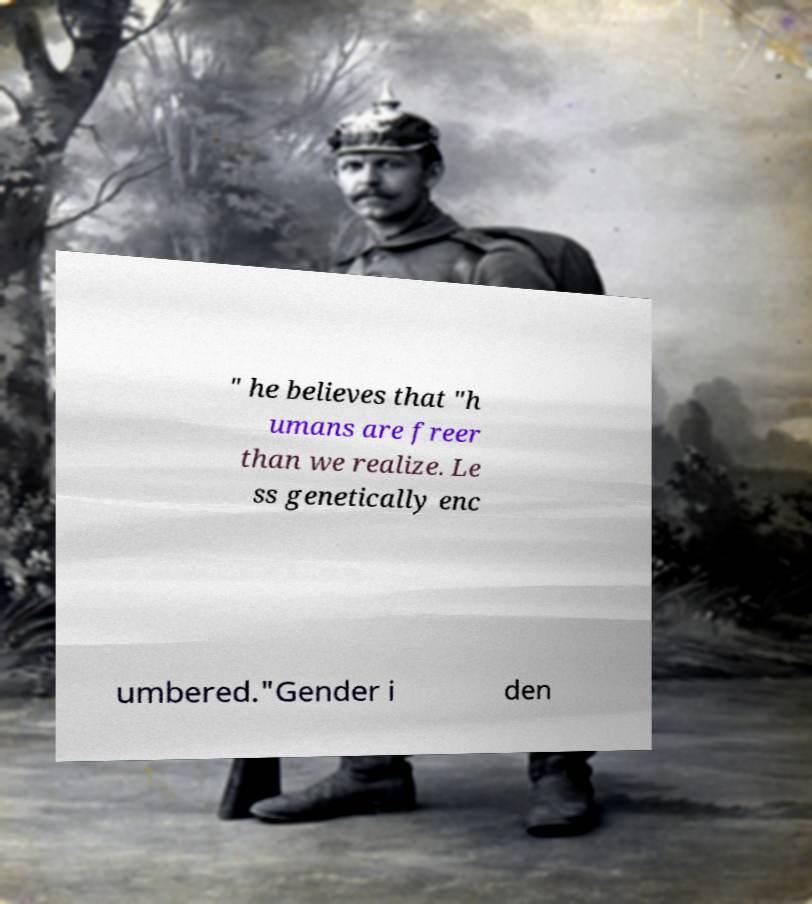I need the written content from this picture converted into text. Can you do that? " he believes that "h umans are freer than we realize. Le ss genetically enc umbered."Gender i den 